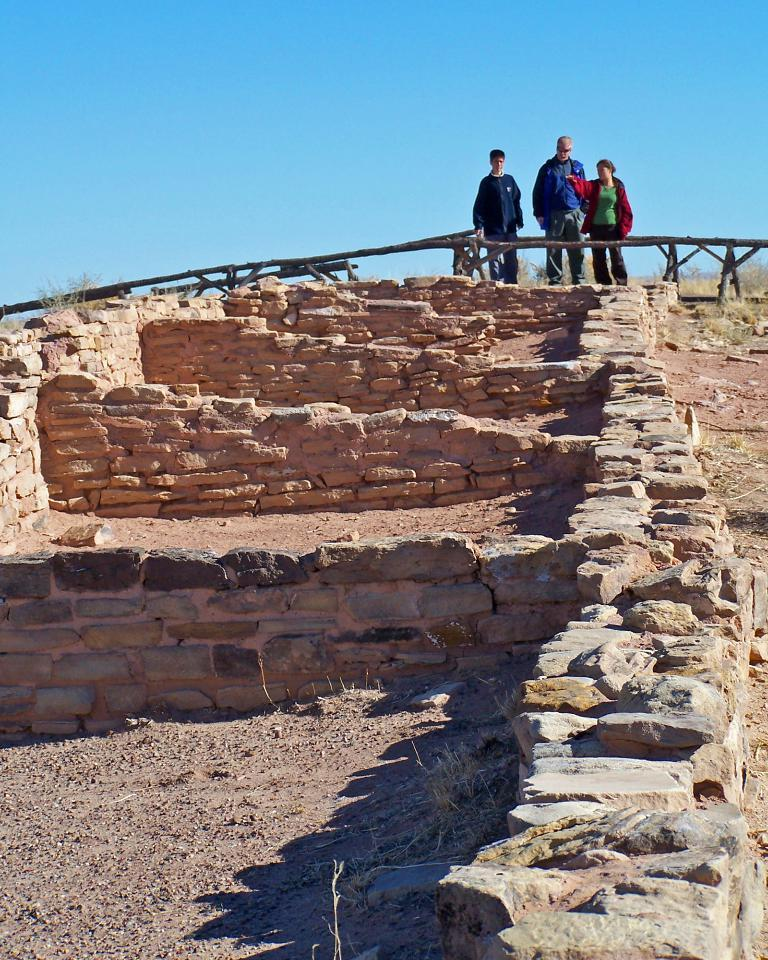What material is the wall made of in the image? The wall in the image is made of stones. How many people are present in the image? There are three persons in the image. What color is the sky in the image? The sky is visible in the image and is blue. What type of car can be seen parked near the wall in the image? There is no car present in the image; it only features a wall made of stones, a blue sky, and three persons. 